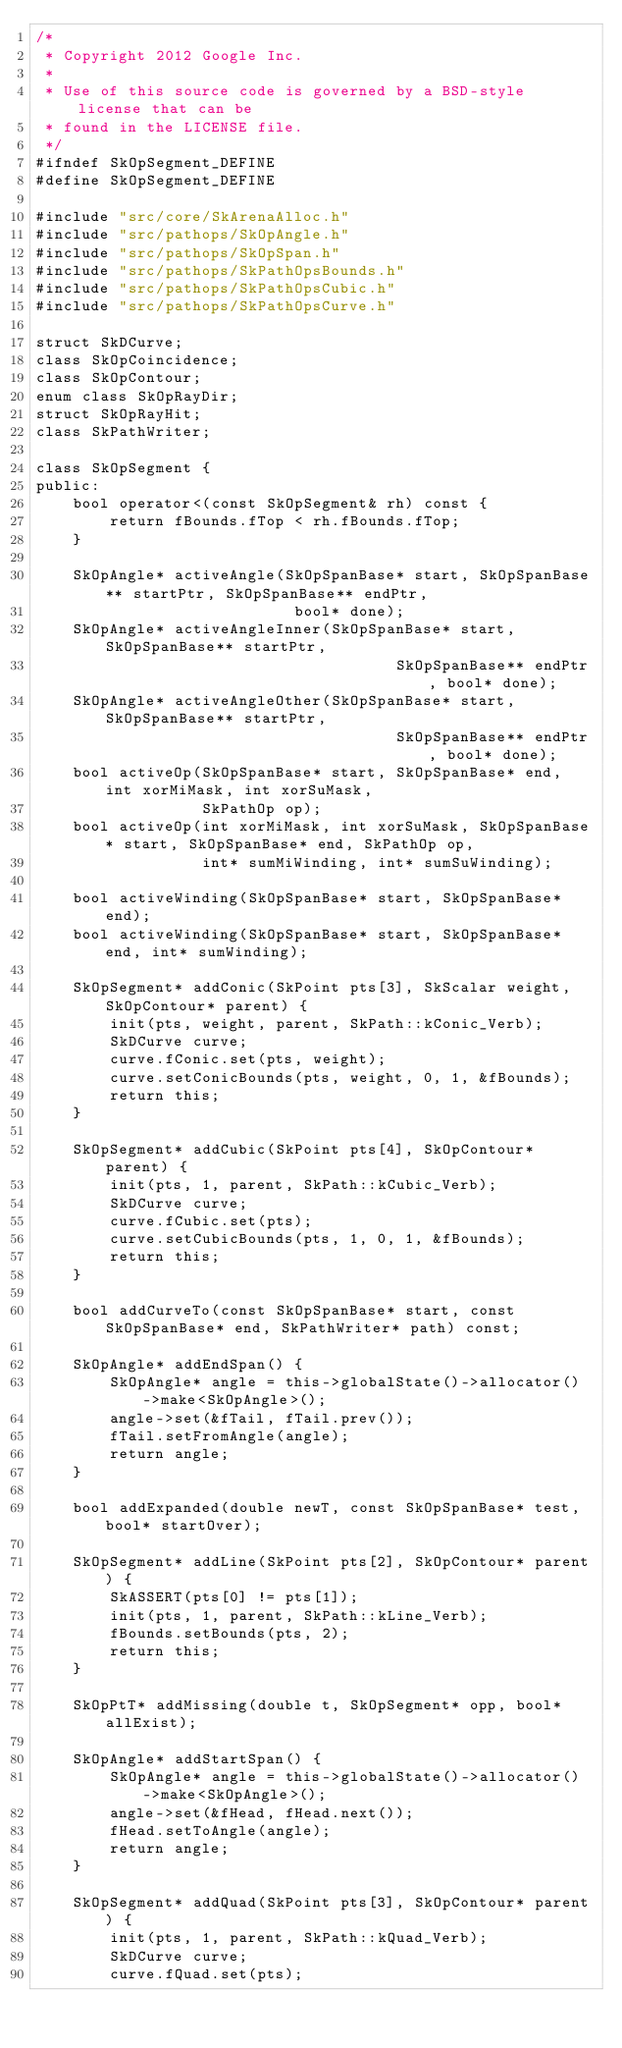Convert code to text. <code><loc_0><loc_0><loc_500><loc_500><_C_>/*
 * Copyright 2012 Google Inc.
 *
 * Use of this source code is governed by a BSD-style license that can be
 * found in the LICENSE file.
 */
#ifndef SkOpSegment_DEFINE
#define SkOpSegment_DEFINE

#include "src/core/SkArenaAlloc.h"
#include "src/pathops/SkOpAngle.h"
#include "src/pathops/SkOpSpan.h"
#include "src/pathops/SkPathOpsBounds.h"
#include "src/pathops/SkPathOpsCubic.h"
#include "src/pathops/SkPathOpsCurve.h"

struct SkDCurve;
class SkOpCoincidence;
class SkOpContour;
enum class SkOpRayDir;
struct SkOpRayHit;
class SkPathWriter;

class SkOpSegment {
public:
    bool operator<(const SkOpSegment& rh) const {
        return fBounds.fTop < rh.fBounds.fTop;
    }

    SkOpAngle* activeAngle(SkOpSpanBase* start, SkOpSpanBase** startPtr, SkOpSpanBase** endPtr,
                            bool* done);
    SkOpAngle* activeAngleInner(SkOpSpanBase* start, SkOpSpanBase** startPtr,
                                       SkOpSpanBase** endPtr, bool* done);
    SkOpAngle* activeAngleOther(SkOpSpanBase* start, SkOpSpanBase** startPtr,
                                       SkOpSpanBase** endPtr, bool* done);
    bool activeOp(SkOpSpanBase* start, SkOpSpanBase* end, int xorMiMask, int xorSuMask,
                  SkPathOp op);
    bool activeOp(int xorMiMask, int xorSuMask, SkOpSpanBase* start, SkOpSpanBase* end, SkPathOp op,
                  int* sumMiWinding, int* sumSuWinding);

    bool activeWinding(SkOpSpanBase* start, SkOpSpanBase* end);
    bool activeWinding(SkOpSpanBase* start, SkOpSpanBase* end, int* sumWinding);

    SkOpSegment* addConic(SkPoint pts[3], SkScalar weight, SkOpContour* parent) {
        init(pts, weight, parent, SkPath::kConic_Verb);
        SkDCurve curve;
        curve.fConic.set(pts, weight);
        curve.setConicBounds(pts, weight, 0, 1, &fBounds);
        return this;
    }

    SkOpSegment* addCubic(SkPoint pts[4], SkOpContour* parent) {
        init(pts, 1, parent, SkPath::kCubic_Verb);
        SkDCurve curve;
        curve.fCubic.set(pts);
        curve.setCubicBounds(pts, 1, 0, 1, &fBounds);
        return this;
    }

    bool addCurveTo(const SkOpSpanBase* start, const SkOpSpanBase* end, SkPathWriter* path) const;

    SkOpAngle* addEndSpan() {
        SkOpAngle* angle = this->globalState()->allocator()->make<SkOpAngle>();
        angle->set(&fTail, fTail.prev());
        fTail.setFromAngle(angle);
        return angle;
    }

    bool addExpanded(double newT, const SkOpSpanBase* test, bool* startOver);

    SkOpSegment* addLine(SkPoint pts[2], SkOpContour* parent) {
        SkASSERT(pts[0] != pts[1]);
        init(pts, 1, parent, SkPath::kLine_Verb);
        fBounds.setBounds(pts, 2);
        return this;
    }

    SkOpPtT* addMissing(double t, SkOpSegment* opp, bool* allExist);

    SkOpAngle* addStartSpan() {
        SkOpAngle* angle = this->globalState()->allocator()->make<SkOpAngle>();
        angle->set(&fHead, fHead.next());
        fHead.setToAngle(angle);
        return angle;
    }

    SkOpSegment* addQuad(SkPoint pts[3], SkOpContour* parent) {
        init(pts, 1, parent, SkPath::kQuad_Verb);
        SkDCurve curve;
        curve.fQuad.set(pts);</code> 